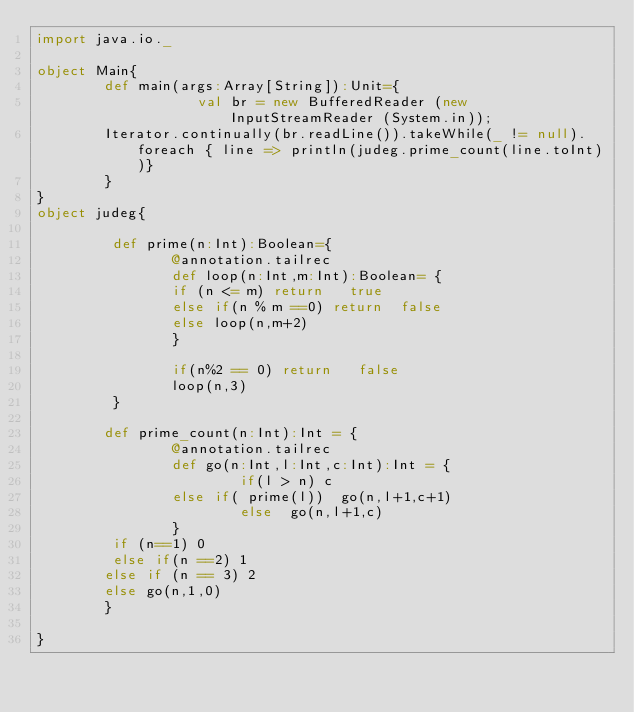Convert code to text. <code><loc_0><loc_0><loc_500><loc_500><_Scala_>import java.io._

object Main{
        def main(args:Array[String]):Unit={
                   val br = new BufferedReader (new InputStreamReader (System.in));
        Iterator.continually(br.readLine()).takeWhile(_ != null).foreach { line => println(judeg.prime_count(line.toInt))}
        }
}
object judeg{

         def prime(n:Int):Boolean={
                @annotation.tailrec
                def loop(n:Int,m:Int):Boolean= {
                if (n <= m) return   true
                else if(n % m ==0) return  false
                else loop(n,m+2)
                }

                if(n%2 == 0) return   false
                loop(n,3)
         }

        def prime_count(n:Int):Int = {
                @annotation.tailrec
                def go(n:Int,l:Int,c:Int):Int = {
                        if(l > n) c
                else if( prime(l))  go(n,l+1,c+1)
                        else  go(n,l+1,c)
                }
         if (n==1) 0
         else if(n ==2) 1
        else if (n == 3) 2
        else go(n,1,0)
        }

}</code> 